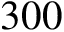<formula> <loc_0><loc_0><loc_500><loc_500>3 0 0</formula> 